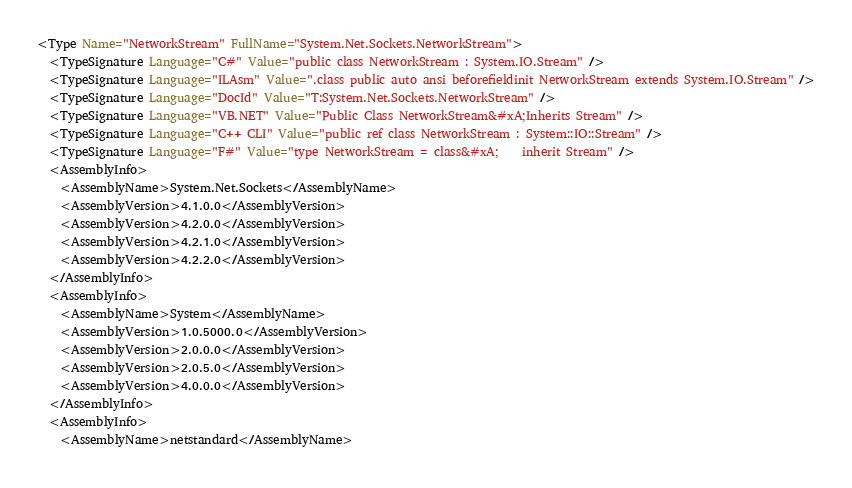Convert code to text. <code><loc_0><loc_0><loc_500><loc_500><_XML_><Type Name="NetworkStream" FullName="System.Net.Sockets.NetworkStream">
  <TypeSignature Language="C#" Value="public class NetworkStream : System.IO.Stream" />
  <TypeSignature Language="ILAsm" Value=".class public auto ansi beforefieldinit NetworkStream extends System.IO.Stream" />
  <TypeSignature Language="DocId" Value="T:System.Net.Sockets.NetworkStream" />
  <TypeSignature Language="VB.NET" Value="Public Class NetworkStream&#xA;Inherits Stream" />
  <TypeSignature Language="C++ CLI" Value="public ref class NetworkStream : System::IO::Stream" />
  <TypeSignature Language="F#" Value="type NetworkStream = class&#xA;    inherit Stream" />
  <AssemblyInfo>
    <AssemblyName>System.Net.Sockets</AssemblyName>
    <AssemblyVersion>4.1.0.0</AssemblyVersion>
    <AssemblyVersion>4.2.0.0</AssemblyVersion>
    <AssemblyVersion>4.2.1.0</AssemblyVersion>
    <AssemblyVersion>4.2.2.0</AssemblyVersion>
  </AssemblyInfo>
  <AssemblyInfo>
    <AssemblyName>System</AssemblyName>
    <AssemblyVersion>1.0.5000.0</AssemblyVersion>
    <AssemblyVersion>2.0.0.0</AssemblyVersion>
    <AssemblyVersion>2.0.5.0</AssemblyVersion>
    <AssemblyVersion>4.0.0.0</AssemblyVersion>
  </AssemblyInfo>
  <AssemblyInfo>
    <AssemblyName>netstandard</AssemblyName></code> 